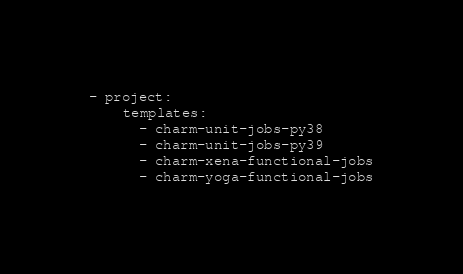<code> <loc_0><loc_0><loc_500><loc_500><_YAML_>- project:
    templates:
      - charm-unit-jobs-py38
      - charm-unit-jobs-py39
      - charm-xena-functional-jobs
      - charm-yoga-functional-jobs

</code> 